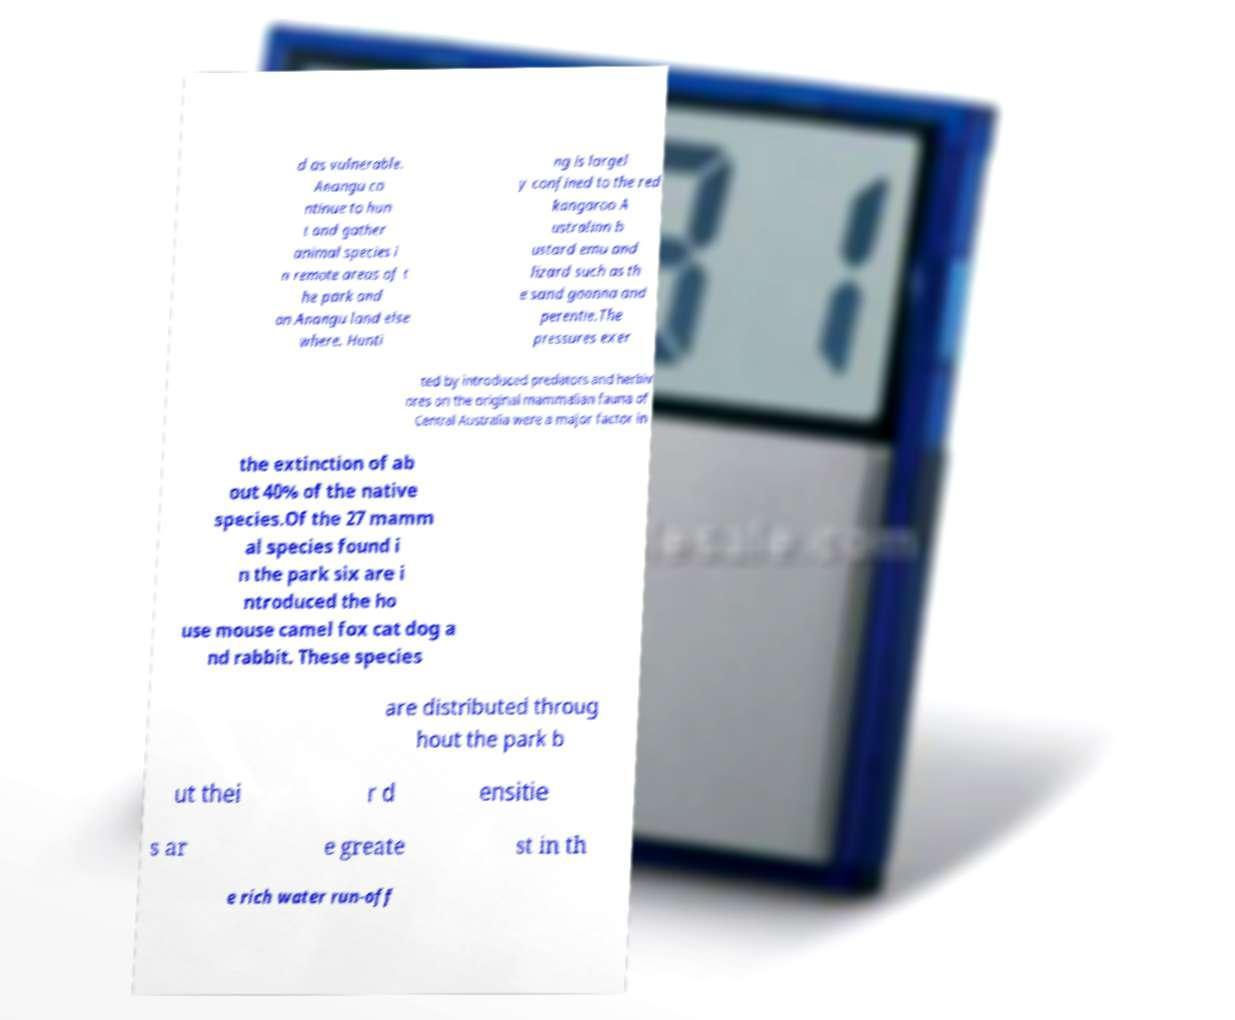Can you read and provide the text displayed in the image?This photo seems to have some interesting text. Can you extract and type it out for me? d as vulnerable. Anangu co ntinue to hun t and gather animal species i n remote areas of t he park and on Anangu land else where. Hunti ng is largel y confined to the red kangaroo A ustralian b ustard emu and lizard such as th e sand goanna and perentie.The pressures exer ted by introduced predators and herbiv ores on the original mammalian fauna of Central Australia were a major factor in the extinction of ab out 40% of the native species.Of the 27 mamm al species found i n the park six are i ntroduced the ho use mouse camel fox cat dog a nd rabbit. These species are distributed throug hout the park b ut thei r d ensitie s ar e greate st in th e rich water run-off 